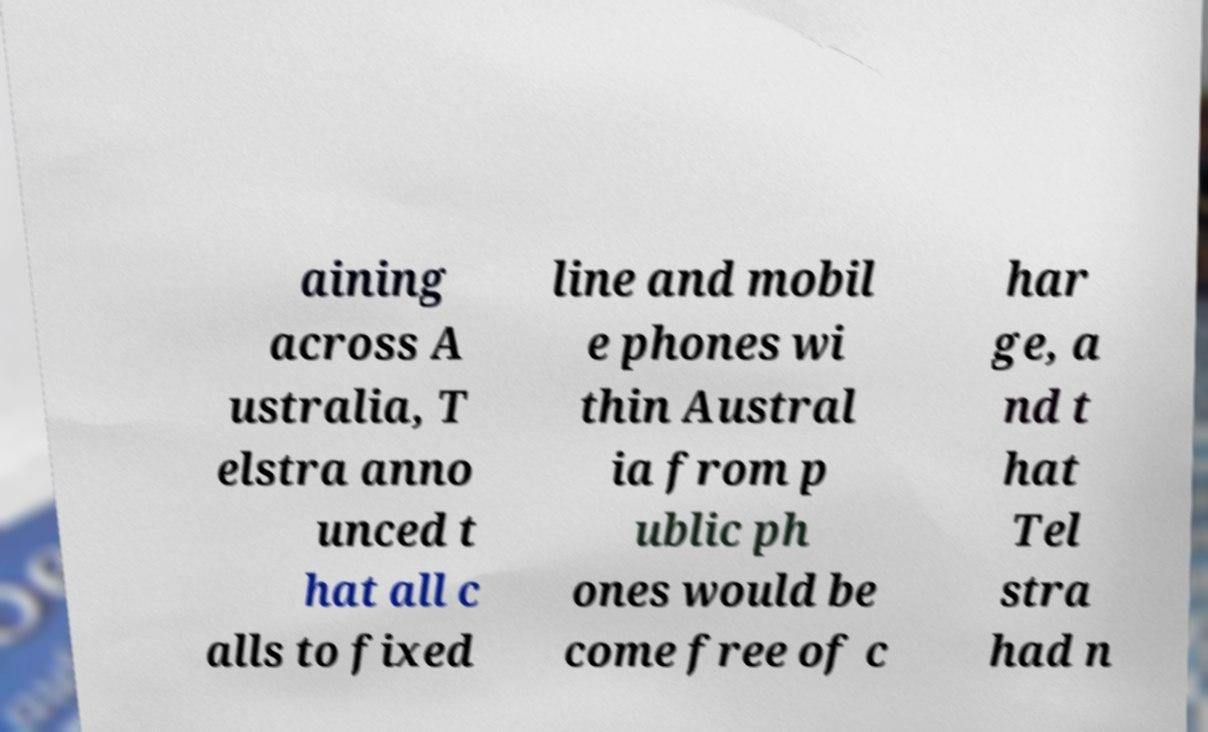Could you extract and type out the text from this image? aining across A ustralia, T elstra anno unced t hat all c alls to fixed line and mobil e phones wi thin Austral ia from p ublic ph ones would be come free of c har ge, a nd t hat Tel stra had n 